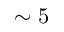Convert formula to latex. <formula><loc_0><loc_0><loc_500><loc_500>\sim 5</formula> 